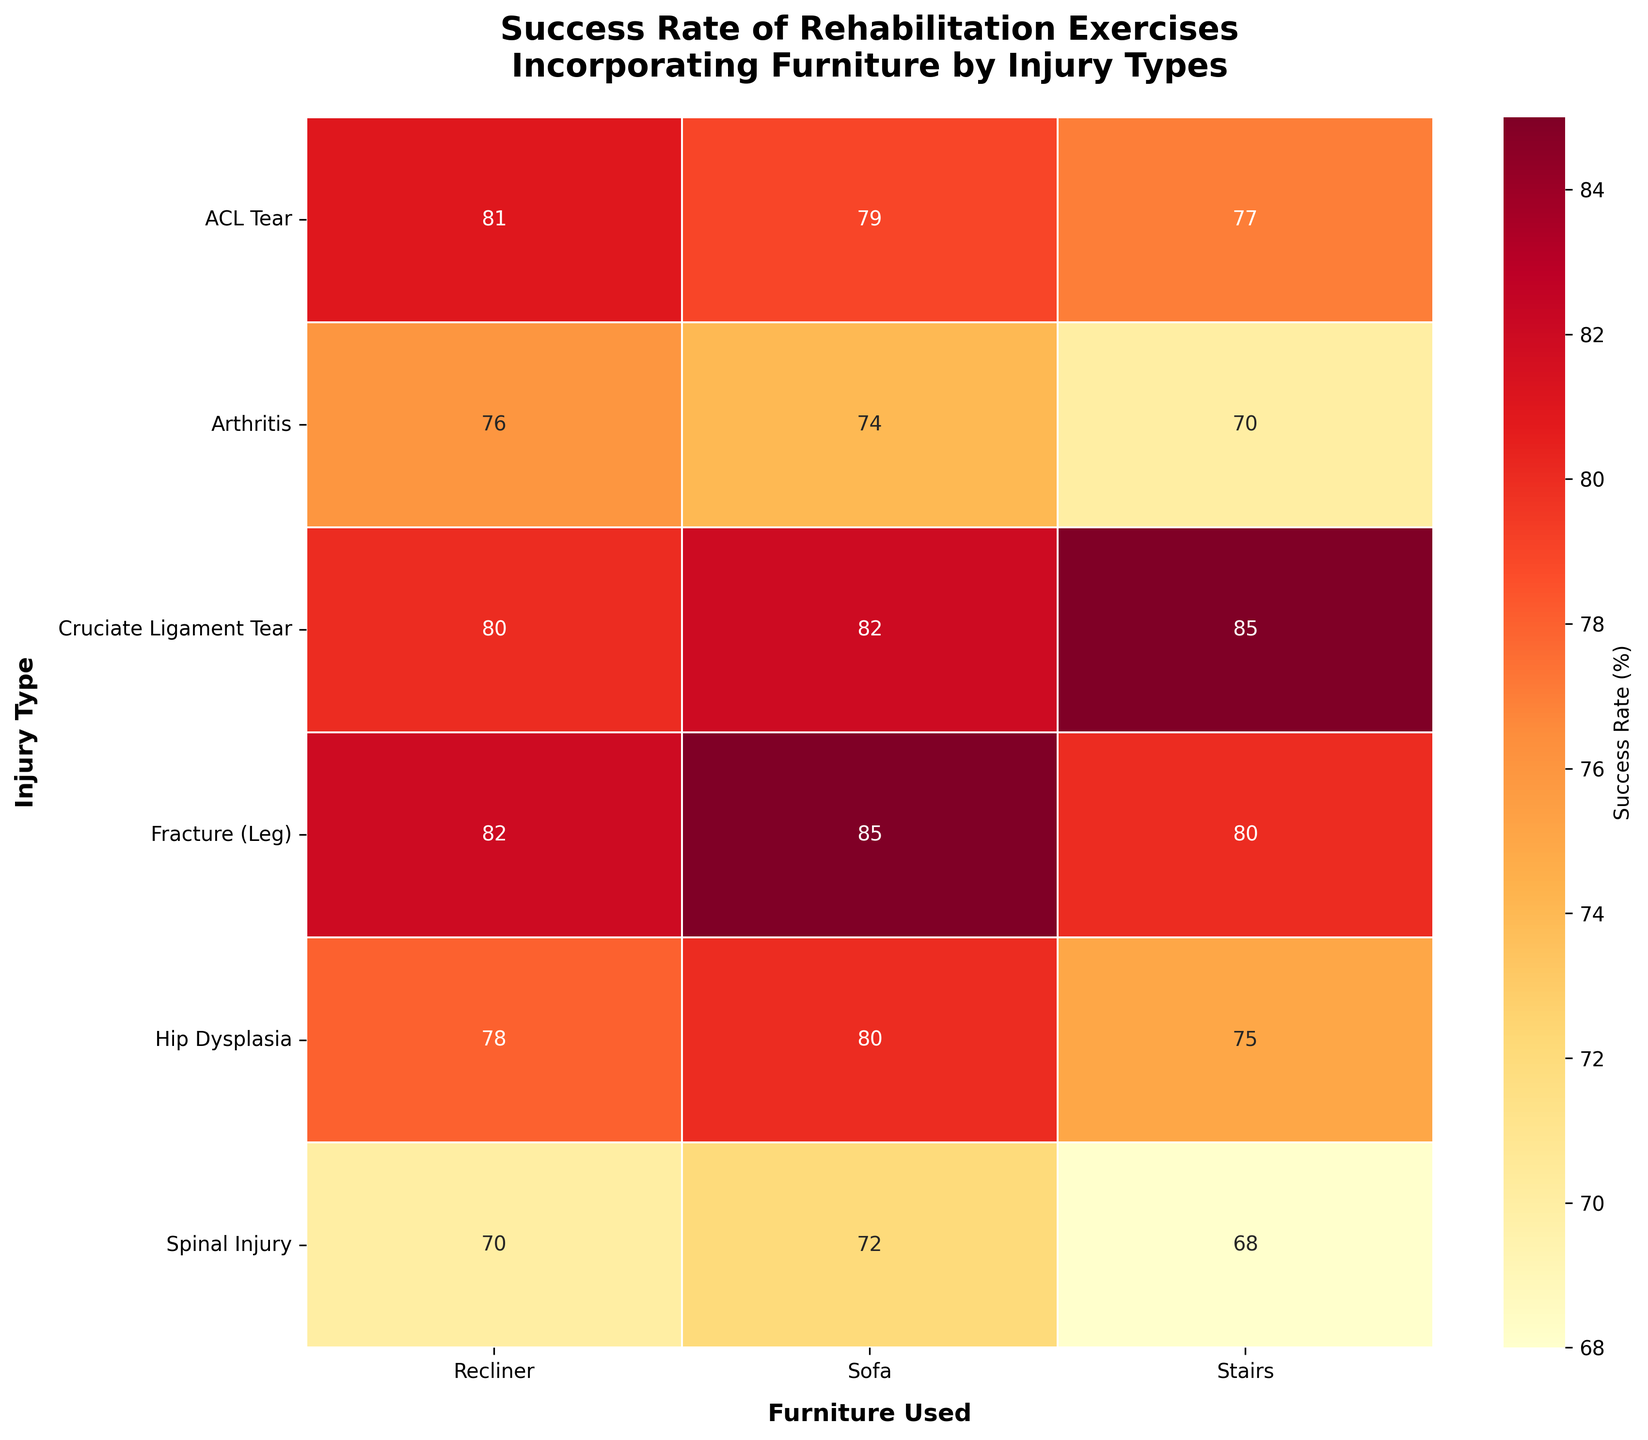What is the title of the heatmap? The title of the heatmap is displayed prominently at the top of the figure.
Answer: Success Rate of Rehabilitation Exercises Incorporating Furniture by Injury Types What is the highest success rate shown on the heatmap? Look across all the values in the heatmap and identify the highest number.
Answer: 85% Which combination of injury type and furniture used has the highest success rate? Find the cell with the highest success rate and check which injury type and furniture it corresponds to.
Answer: Cruciate Ligament Tear, Stairs / Fracture (Leg), Sofa What is the success rate for 'ACL Tear' when using a recliner? Find the row for 'ACL Tear' and the column for 'Recliner' and read the value.
Answer: 81% What is the average success rate for 'Arthritis' across all types of furniture? Sum the success rates for 'Stairs', 'Sofa', and 'Recliner' under 'Arthritis' and divide by 3. (70 + 74 + 76) / 3 = 73.33
Answer: 73.33% Which injury type has the lowest average success rate across all furniture types? Calculate the average success rate for each injury type, and then find the one with the lowest average.
Answer: Spinal Injury How does the success rate for 'Sofa' compare between 'Hip Dysplasia' and 'Spinal Injury'? Compare the values for 'Sofa' under 'Hip Dysplasia' and 'Spinal Injury'.
Answer: 80 for Hip Dysplasia; 72 for Spinal Injury. Hip Dysplasia is higher For which injury type does 'Recliner' offer the highest success rate compared to other furniture types? For each injury type, compare the success rates for 'Recliner', 'Stairs', and 'Sofa' and determine the highest.
Answer: ACL Tear What is the overall trend in success rates for 'Stairs' across all injury types? Look at the success rates for 'Stairs' across all injury types and determine if they generally increase, decrease, or vary significantly.
Answer: Vary significantly Which furniture type shows the most consistent success rates across injury types? Compare the range of success rates for 'Stairs', 'Sofa', and 'Recliner' across all injury types to find the most consistent one.
Answer: Recliner 